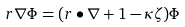Convert formula to latex. <formula><loc_0><loc_0><loc_500><loc_500>r \nabla \Phi = ( r \bullet \nabla + 1 - \kappa \zeta ) \Phi</formula> 